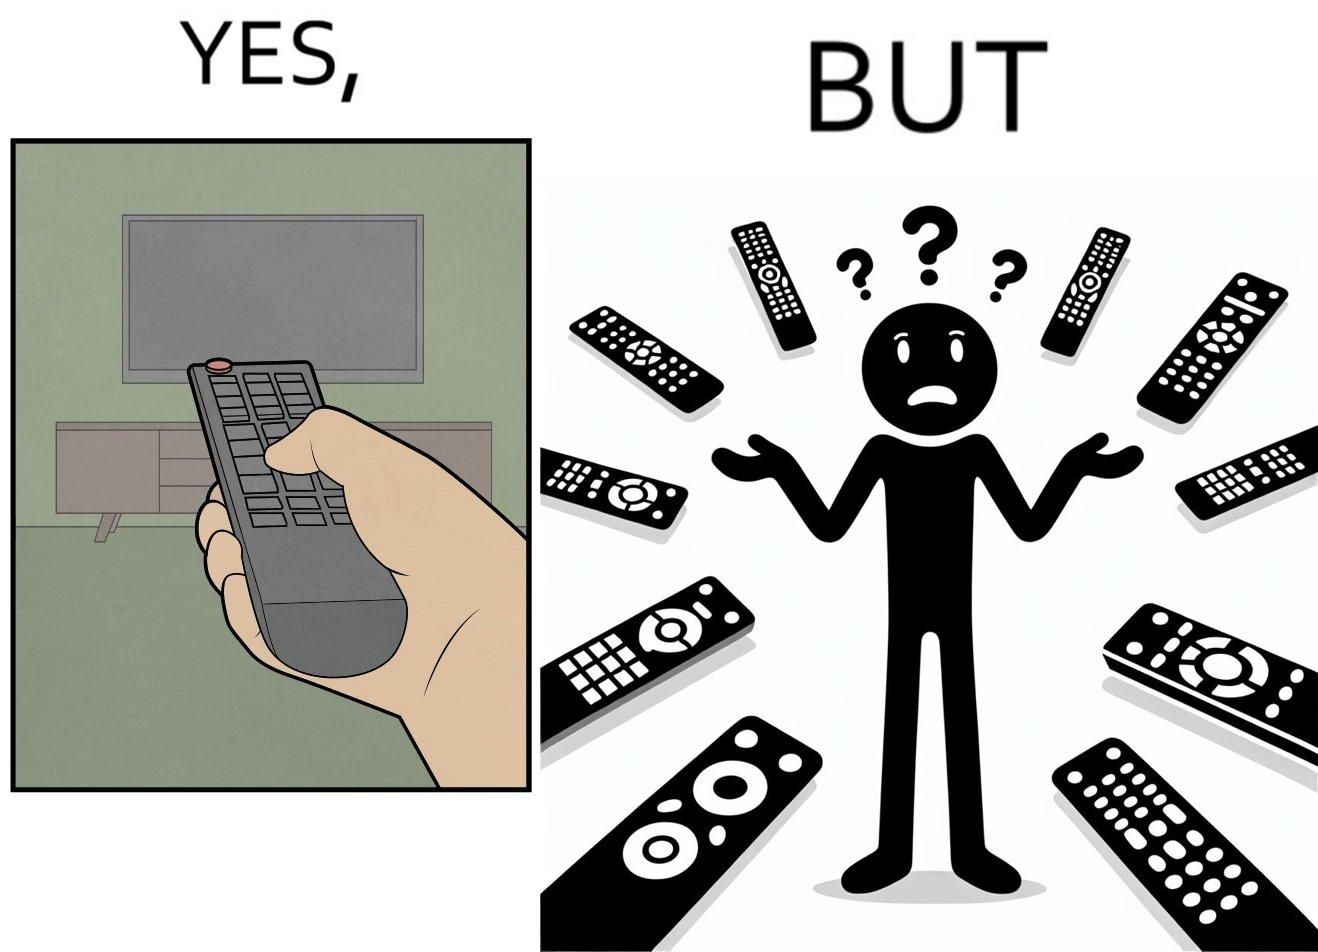Provide a description of this image. The images are funny since they show how even though TV remotes are supposed to make operating TVs easier, having multiple similar looking remotes  for everything only makes it more difficult for the user to use the right one 